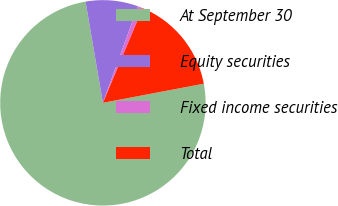Convert chart. <chart><loc_0><loc_0><loc_500><loc_500><pie_chart><fcel>At September 30<fcel>Equity securities<fcel>Fixed income securities<fcel>Total<nl><fcel>75.29%<fcel>8.24%<fcel>0.79%<fcel>15.69%<nl></chart> 